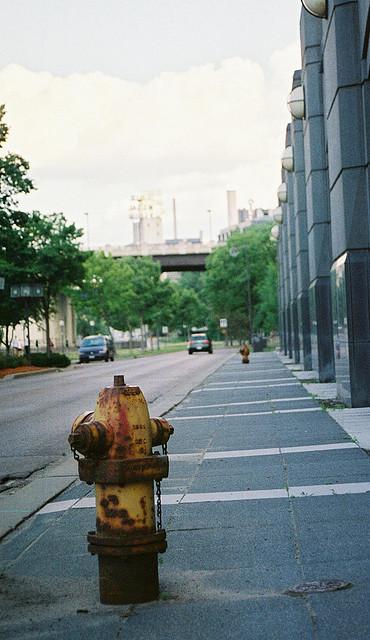How many cars are pictured?
Keep it brief. 2. Is the fire hydrant new?
Answer briefly. No. Is there a pigeon?
Keep it brief. No. What color is the hydrant?
Be succinct. Yellow. 